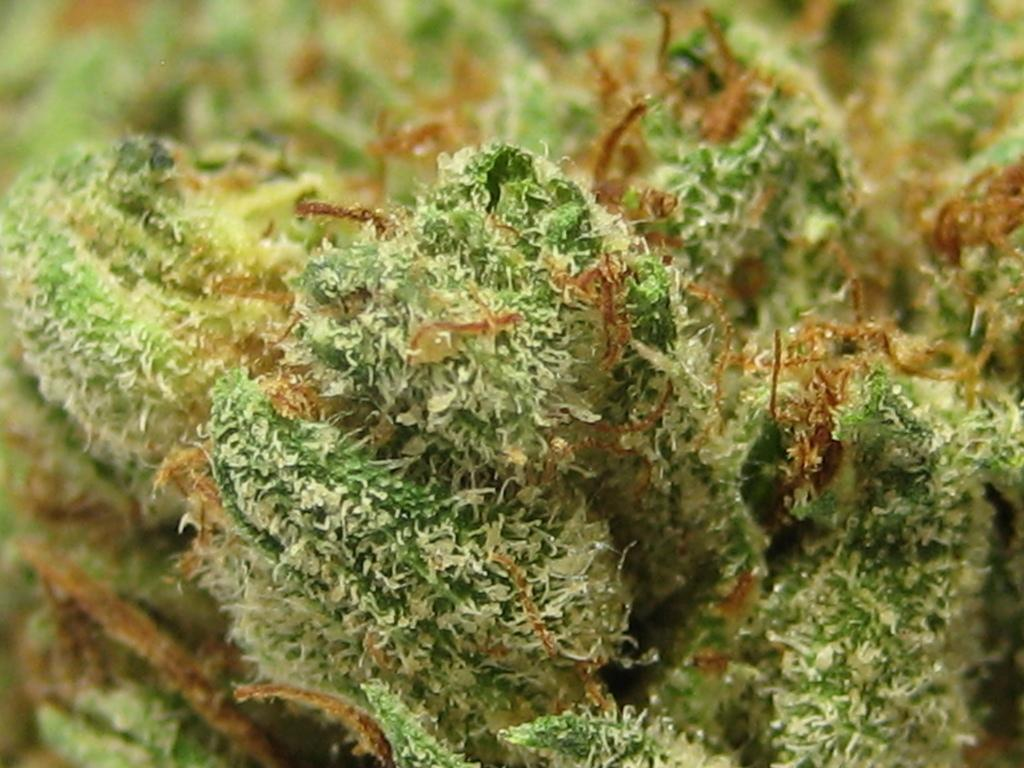What type of plant is in the picture? There is a liverwort plant in the picture. What color is the liverwort plant? The liverwort plant is green in color. Can you describe the background of the image? The background of the image is blurred. What type of insurance is being advertised in the image? There is no insurance being advertised in the image; it features a liverwort plant. Where is the nearest park to the location of the image? The location of the image cannot be determined from the provided facts, so it is impossible to determine the nearest park. 